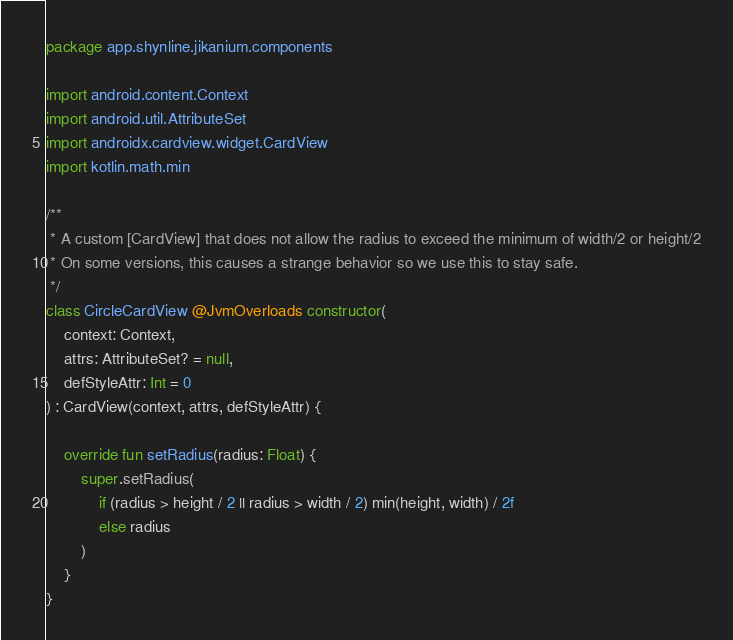<code> <loc_0><loc_0><loc_500><loc_500><_Kotlin_>package app.shynline.jikanium.components

import android.content.Context
import android.util.AttributeSet
import androidx.cardview.widget.CardView
import kotlin.math.min

/**
 * A custom [CardView] that does not allow the radius to exceed the minimum of width/2 or height/2
 * On some versions, this causes a strange behavior so we use this to stay safe.
 */
class CircleCardView @JvmOverloads constructor(
    context: Context,
    attrs: AttributeSet? = null,
    defStyleAttr: Int = 0
) : CardView(context, attrs, defStyleAttr) {

    override fun setRadius(radius: Float) {
        super.setRadius(
            if (radius > height / 2 || radius > width / 2) min(height, width) / 2f
            else radius
        )
    }
}</code> 